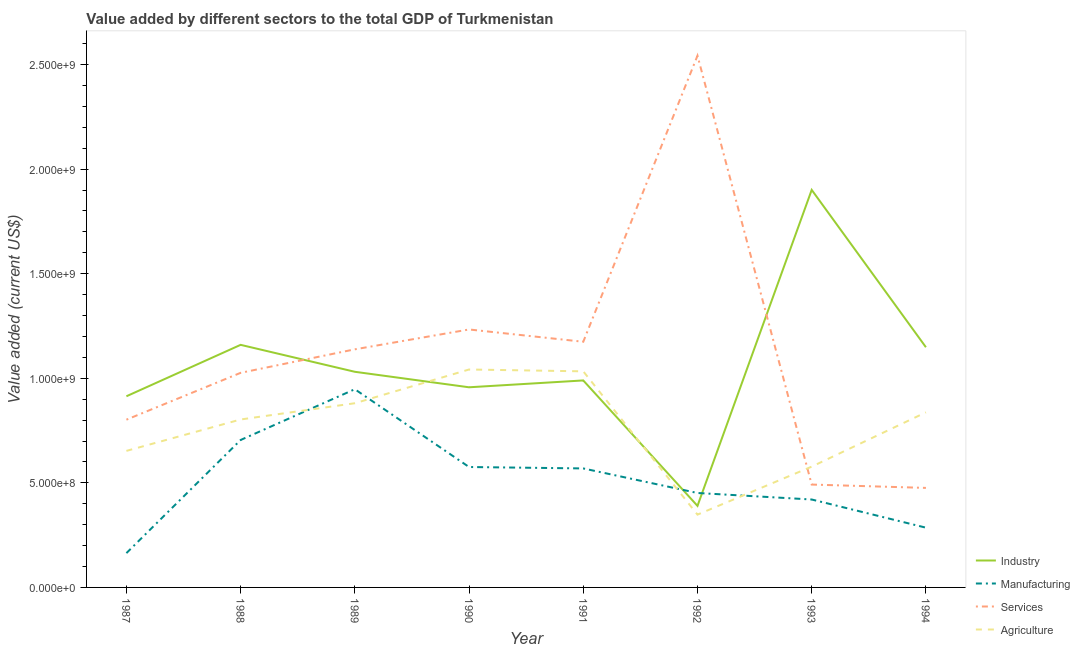Does the line corresponding to value added by manufacturing sector intersect with the line corresponding to value added by agricultural sector?
Provide a short and direct response. Yes. Is the number of lines equal to the number of legend labels?
Your answer should be compact. Yes. What is the value added by services sector in 1992?
Provide a succinct answer. 2.54e+09. Across all years, what is the maximum value added by agricultural sector?
Your answer should be compact. 1.04e+09. Across all years, what is the minimum value added by agricultural sector?
Offer a terse response. 3.48e+08. In which year was the value added by industrial sector maximum?
Ensure brevity in your answer.  1993. In which year was the value added by agricultural sector minimum?
Give a very brief answer. 1992. What is the total value added by agricultural sector in the graph?
Ensure brevity in your answer.  6.17e+09. What is the difference between the value added by industrial sector in 1990 and that in 1994?
Ensure brevity in your answer.  -1.92e+08. What is the difference between the value added by industrial sector in 1992 and the value added by manufacturing sector in 1988?
Your response must be concise. -3.15e+08. What is the average value added by services sector per year?
Provide a succinct answer. 1.11e+09. In the year 1990, what is the difference between the value added by industrial sector and value added by services sector?
Ensure brevity in your answer.  -2.76e+08. What is the ratio of the value added by industrial sector in 1989 to that in 1994?
Provide a succinct answer. 0.9. Is the value added by services sector in 1988 less than that in 1991?
Offer a terse response. Yes. Is the difference between the value added by manufacturing sector in 1988 and 1993 greater than the difference between the value added by industrial sector in 1988 and 1993?
Your answer should be very brief. Yes. What is the difference between the highest and the second highest value added by industrial sector?
Your answer should be compact. 7.41e+08. What is the difference between the highest and the lowest value added by agricultural sector?
Your answer should be very brief. 6.94e+08. Is it the case that in every year, the sum of the value added by services sector and value added by industrial sector is greater than the sum of value added by agricultural sector and value added by manufacturing sector?
Provide a short and direct response. No. Is it the case that in every year, the sum of the value added by industrial sector and value added by manufacturing sector is greater than the value added by services sector?
Provide a short and direct response. No. How many lines are there?
Offer a very short reply. 4. How many years are there in the graph?
Your answer should be compact. 8. What is the difference between two consecutive major ticks on the Y-axis?
Give a very brief answer. 5.00e+08. Does the graph contain any zero values?
Provide a succinct answer. No. Does the graph contain grids?
Keep it short and to the point. No. Where does the legend appear in the graph?
Give a very brief answer. Bottom right. How many legend labels are there?
Your response must be concise. 4. How are the legend labels stacked?
Your answer should be compact. Vertical. What is the title of the graph?
Offer a terse response. Value added by different sectors to the total GDP of Turkmenistan. What is the label or title of the Y-axis?
Offer a terse response. Value added (current US$). What is the Value added (current US$) in Industry in 1987?
Offer a terse response. 9.14e+08. What is the Value added (current US$) of Manufacturing in 1987?
Provide a succinct answer. 1.64e+08. What is the Value added (current US$) in Services in 1987?
Offer a terse response. 8.02e+08. What is the Value added (current US$) of Agriculture in 1987?
Keep it short and to the point. 6.53e+08. What is the Value added (current US$) in Industry in 1988?
Provide a succinct answer. 1.16e+09. What is the Value added (current US$) in Manufacturing in 1988?
Offer a very short reply. 7.05e+08. What is the Value added (current US$) of Services in 1988?
Provide a short and direct response. 1.03e+09. What is the Value added (current US$) of Agriculture in 1988?
Your answer should be compact. 8.03e+08. What is the Value added (current US$) in Industry in 1989?
Ensure brevity in your answer.  1.03e+09. What is the Value added (current US$) in Manufacturing in 1989?
Your answer should be compact. 9.48e+08. What is the Value added (current US$) in Services in 1989?
Offer a terse response. 1.14e+09. What is the Value added (current US$) in Agriculture in 1989?
Your answer should be very brief. 8.81e+08. What is the Value added (current US$) of Industry in 1990?
Give a very brief answer. 9.57e+08. What is the Value added (current US$) in Manufacturing in 1990?
Provide a short and direct response. 5.76e+08. What is the Value added (current US$) in Services in 1990?
Offer a terse response. 1.23e+09. What is the Value added (current US$) in Agriculture in 1990?
Your answer should be compact. 1.04e+09. What is the Value added (current US$) in Industry in 1991?
Give a very brief answer. 9.90e+08. What is the Value added (current US$) of Manufacturing in 1991?
Make the answer very short. 5.69e+08. What is the Value added (current US$) in Services in 1991?
Your answer should be very brief. 1.17e+09. What is the Value added (current US$) in Agriculture in 1991?
Keep it short and to the point. 1.03e+09. What is the Value added (current US$) in Industry in 1992?
Your response must be concise. 3.90e+08. What is the Value added (current US$) in Manufacturing in 1992?
Your answer should be compact. 4.52e+08. What is the Value added (current US$) of Services in 1992?
Provide a short and direct response. 2.54e+09. What is the Value added (current US$) in Agriculture in 1992?
Give a very brief answer. 3.48e+08. What is the Value added (current US$) in Industry in 1993?
Your answer should be very brief. 1.90e+09. What is the Value added (current US$) in Manufacturing in 1993?
Make the answer very short. 4.20e+08. What is the Value added (current US$) of Services in 1993?
Keep it short and to the point. 4.92e+08. What is the Value added (current US$) of Agriculture in 1993?
Provide a short and direct response. 5.77e+08. What is the Value added (current US$) of Industry in 1994?
Keep it short and to the point. 1.15e+09. What is the Value added (current US$) in Manufacturing in 1994?
Provide a short and direct response. 2.86e+08. What is the Value added (current US$) of Services in 1994?
Offer a terse response. 4.76e+08. What is the Value added (current US$) of Agriculture in 1994?
Your answer should be very brief. 8.37e+08. Across all years, what is the maximum Value added (current US$) of Industry?
Provide a short and direct response. 1.90e+09. Across all years, what is the maximum Value added (current US$) in Manufacturing?
Make the answer very short. 9.48e+08. Across all years, what is the maximum Value added (current US$) in Services?
Your answer should be very brief. 2.54e+09. Across all years, what is the maximum Value added (current US$) of Agriculture?
Offer a terse response. 1.04e+09. Across all years, what is the minimum Value added (current US$) in Industry?
Offer a terse response. 3.90e+08. Across all years, what is the minimum Value added (current US$) of Manufacturing?
Give a very brief answer. 1.64e+08. Across all years, what is the minimum Value added (current US$) of Services?
Your answer should be compact. 4.76e+08. Across all years, what is the minimum Value added (current US$) of Agriculture?
Your answer should be compact. 3.48e+08. What is the total Value added (current US$) in Industry in the graph?
Give a very brief answer. 8.49e+09. What is the total Value added (current US$) in Manufacturing in the graph?
Provide a succinct answer. 4.12e+09. What is the total Value added (current US$) in Services in the graph?
Your answer should be compact. 8.88e+09. What is the total Value added (current US$) in Agriculture in the graph?
Your answer should be compact. 6.17e+09. What is the difference between the Value added (current US$) of Industry in 1987 and that in 1988?
Offer a terse response. -2.46e+08. What is the difference between the Value added (current US$) in Manufacturing in 1987 and that in 1988?
Your answer should be very brief. -5.41e+08. What is the difference between the Value added (current US$) in Services in 1987 and that in 1988?
Your answer should be compact. -2.24e+08. What is the difference between the Value added (current US$) in Agriculture in 1987 and that in 1988?
Your answer should be very brief. -1.50e+08. What is the difference between the Value added (current US$) of Industry in 1987 and that in 1989?
Provide a succinct answer. -1.17e+08. What is the difference between the Value added (current US$) in Manufacturing in 1987 and that in 1989?
Offer a terse response. -7.84e+08. What is the difference between the Value added (current US$) in Services in 1987 and that in 1989?
Your answer should be very brief. -3.36e+08. What is the difference between the Value added (current US$) in Agriculture in 1987 and that in 1989?
Offer a very short reply. -2.28e+08. What is the difference between the Value added (current US$) of Industry in 1987 and that in 1990?
Give a very brief answer. -4.30e+07. What is the difference between the Value added (current US$) of Manufacturing in 1987 and that in 1990?
Make the answer very short. -4.12e+08. What is the difference between the Value added (current US$) in Services in 1987 and that in 1990?
Make the answer very short. -4.31e+08. What is the difference between the Value added (current US$) in Agriculture in 1987 and that in 1990?
Ensure brevity in your answer.  -3.89e+08. What is the difference between the Value added (current US$) in Industry in 1987 and that in 1991?
Your answer should be very brief. -7.57e+07. What is the difference between the Value added (current US$) of Manufacturing in 1987 and that in 1991?
Your answer should be compact. -4.05e+08. What is the difference between the Value added (current US$) of Services in 1987 and that in 1991?
Make the answer very short. -3.73e+08. What is the difference between the Value added (current US$) in Agriculture in 1987 and that in 1991?
Provide a succinct answer. -3.80e+08. What is the difference between the Value added (current US$) of Industry in 1987 and that in 1992?
Offer a very short reply. 5.24e+08. What is the difference between the Value added (current US$) in Manufacturing in 1987 and that in 1992?
Your answer should be compact. -2.87e+08. What is the difference between the Value added (current US$) in Services in 1987 and that in 1992?
Your answer should be compact. -1.74e+09. What is the difference between the Value added (current US$) in Agriculture in 1987 and that in 1992?
Your response must be concise. 3.05e+08. What is the difference between the Value added (current US$) of Industry in 1987 and that in 1993?
Provide a short and direct response. -9.87e+08. What is the difference between the Value added (current US$) in Manufacturing in 1987 and that in 1993?
Give a very brief answer. -2.56e+08. What is the difference between the Value added (current US$) in Services in 1987 and that in 1993?
Your answer should be compact. 3.10e+08. What is the difference between the Value added (current US$) in Agriculture in 1987 and that in 1993?
Your response must be concise. 7.53e+07. What is the difference between the Value added (current US$) in Industry in 1987 and that in 1994?
Ensure brevity in your answer.  -2.34e+08. What is the difference between the Value added (current US$) of Manufacturing in 1987 and that in 1994?
Make the answer very short. -1.22e+08. What is the difference between the Value added (current US$) of Services in 1987 and that in 1994?
Give a very brief answer. 3.26e+08. What is the difference between the Value added (current US$) of Agriculture in 1987 and that in 1994?
Offer a very short reply. -1.84e+08. What is the difference between the Value added (current US$) in Industry in 1988 and that in 1989?
Ensure brevity in your answer.  1.29e+08. What is the difference between the Value added (current US$) of Manufacturing in 1988 and that in 1989?
Your answer should be very brief. -2.43e+08. What is the difference between the Value added (current US$) in Services in 1988 and that in 1989?
Make the answer very short. -1.12e+08. What is the difference between the Value added (current US$) of Agriculture in 1988 and that in 1989?
Offer a terse response. -7.77e+07. What is the difference between the Value added (current US$) of Industry in 1988 and that in 1990?
Your answer should be very brief. 2.03e+08. What is the difference between the Value added (current US$) in Manufacturing in 1988 and that in 1990?
Offer a very short reply. 1.29e+08. What is the difference between the Value added (current US$) of Services in 1988 and that in 1990?
Your response must be concise. -2.07e+08. What is the difference between the Value added (current US$) of Agriculture in 1988 and that in 1990?
Your answer should be compact. -2.39e+08. What is the difference between the Value added (current US$) in Industry in 1988 and that in 1991?
Offer a terse response. 1.70e+08. What is the difference between the Value added (current US$) of Manufacturing in 1988 and that in 1991?
Your answer should be very brief. 1.36e+08. What is the difference between the Value added (current US$) in Services in 1988 and that in 1991?
Give a very brief answer. -1.49e+08. What is the difference between the Value added (current US$) in Agriculture in 1988 and that in 1991?
Give a very brief answer. -2.30e+08. What is the difference between the Value added (current US$) in Industry in 1988 and that in 1992?
Your answer should be very brief. 7.70e+08. What is the difference between the Value added (current US$) of Manufacturing in 1988 and that in 1992?
Offer a very short reply. 2.53e+08. What is the difference between the Value added (current US$) of Services in 1988 and that in 1992?
Keep it short and to the point. -1.52e+09. What is the difference between the Value added (current US$) of Agriculture in 1988 and that in 1992?
Keep it short and to the point. 4.55e+08. What is the difference between the Value added (current US$) in Industry in 1988 and that in 1993?
Your answer should be compact. -7.41e+08. What is the difference between the Value added (current US$) of Manufacturing in 1988 and that in 1993?
Make the answer very short. 2.85e+08. What is the difference between the Value added (current US$) in Services in 1988 and that in 1993?
Offer a terse response. 5.34e+08. What is the difference between the Value added (current US$) of Agriculture in 1988 and that in 1993?
Keep it short and to the point. 2.25e+08. What is the difference between the Value added (current US$) in Industry in 1988 and that in 1994?
Ensure brevity in your answer.  1.14e+07. What is the difference between the Value added (current US$) in Manufacturing in 1988 and that in 1994?
Your answer should be compact. 4.19e+08. What is the difference between the Value added (current US$) of Services in 1988 and that in 1994?
Provide a succinct answer. 5.50e+08. What is the difference between the Value added (current US$) in Agriculture in 1988 and that in 1994?
Your response must be concise. -3.41e+07. What is the difference between the Value added (current US$) of Industry in 1989 and that in 1990?
Your answer should be very brief. 7.41e+07. What is the difference between the Value added (current US$) of Manufacturing in 1989 and that in 1990?
Your answer should be compact. 3.72e+08. What is the difference between the Value added (current US$) in Services in 1989 and that in 1990?
Your answer should be compact. -9.49e+07. What is the difference between the Value added (current US$) in Agriculture in 1989 and that in 1990?
Your answer should be very brief. -1.61e+08. What is the difference between the Value added (current US$) in Industry in 1989 and that in 1991?
Your answer should be compact. 4.14e+07. What is the difference between the Value added (current US$) in Manufacturing in 1989 and that in 1991?
Offer a terse response. 3.79e+08. What is the difference between the Value added (current US$) of Services in 1989 and that in 1991?
Your answer should be compact. -3.61e+07. What is the difference between the Value added (current US$) of Agriculture in 1989 and that in 1991?
Your response must be concise. -1.52e+08. What is the difference between the Value added (current US$) in Industry in 1989 and that in 1992?
Your answer should be compact. 6.41e+08. What is the difference between the Value added (current US$) of Manufacturing in 1989 and that in 1992?
Keep it short and to the point. 4.96e+08. What is the difference between the Value added (current US$) in Services in 1989 and that in 1992?
Your response must be concise. -1.40e+09. What is the difference between the Value added (current US$) of Agriculture in 1989 and that in 1992?
Your answer should be compact. 5.33e+08. What is the difference between the Value added (current US$) of Industry in 1989 and that in 1993?
Provide a succinct answer. -8.70e+08. What is the difference between the Value added (current US$) in Manufacturing in 1989 and that in 1993?
Provide a short and direct response. 5.27e+08. What is the difference between the Value added (current US$) of Services in 1989 and that in 1993?
Give a very brief answer. 6.47e+08. What is the difference between the Value added (current US$) in Agriculture in 1989 and that in 1993?
Provide a short and direct response. 3.03e+08. What is the difference between the Value added (current US$) in Industry in 1989 and that in 1994?
Ensure brevity in your answer.  -1.17e+08. What is the difference between the Value added (current US$) in Manufacturing in 1989 and that in 1994?
Your answer should be very brief. 6.62e+08. What is the difference between the Value added (current US$) in Services in 1989 and that in 1994?
Your response must be concise. 6.63e+08. What is the difference between the Value added (current US$) of Agriculture in 1989 and that in 1994?
Make the answer very short. 4.36e+07. What is the difference between the Value added (current US$) in Industry in 1990 and that in 1991?
Keep it short and to the point. -3.28e+07. What is the difference between the Value added (current US$) in Manufacturing in 1990 and that in 1991?
Your answer should be compact. 6.83e+06. What is the difference between the Value added (current US$) in Services in 1990 and that in 1991?
Provide a short and direct response. 5.88e+07. What is the difference between the Value added (current US$) in Agriculture in 1990 and that in 1991?
Keep it short and to the point. 8.80e+06. What is the difference between the Value added (current US$) in Industry in 1990 and that in 1992?
Provide a short and direct response. 5.67e+08. What is the difference between the Value added (current US$) of Manufacturing in 1990 and that in 1992?
Offer a very short reply. 1.24e+08. What is the difference between the Value added (current US$) of Services in 1990 and that in 1992?
Your answer should be compact. -1.31e+09. What is the difference between the Value added (current US$) in Agriculture in 1990 and that in 1992?
Give a very brief answer. 6.94e+08. What is the difference between the Value added (current US$) of Industry in 1990 and that in 1993?
Make the answer very short. -9.44e+08. What is the difference between the Value added (current US$) in Manufacturing in 1990 and that in 1993?
Ensure brevity in your answer.  1.55e+08. What is the difference between the Value added (current US$) of Services in 1990 and that in 1993?
Offer a terse response. 7.41e+08. What is the difference between the Value added (current US$) in Agriculture in 1990 and that in 1993?
Offer a terse response. 4.64e+08. What is the difference between the Value added (current US$) in Industry in 1990 and that in 1994?
Give a very brief answer. -1.92e+08. What is the difference between the Value added (current US$) in Manufacturing in 1990 and that in 1994?
Offer a terse response. 2.90e+08. What is the difference between the Value added (current US$) of Services in 1990 and that in 1994?
Provide a succinct answer. 7.57e+08. What is the difference between the Value added (current US$) of Agriculture in 1990 and that in 1994?
Give a very brief answer. 2.05e+08. What is the difference between the Value added (current US$) of Industry in 1991 and that in 1992?
Make the answer very short. 6.00e+08. What is the difference between the Value added (current US$) of Manufacturing in 1991 and that in 1992?
Ensure brevity in your answer.  1.17e+08. What is the difference between the Value added (current US$) of Services in 1991 and that in 1992?
Your response must be concise. -1.37e+09. What is the difference between the Value added (current US$) in Agriculture in 1991 and that in 1992?
Give a very brief answer. 6.85e+08. What is the difference between the Value added (current US$) of Industry in 1991 and that in 1993?
Offer a terse response. -9.11e+08. What is the difference between the Value added (current US$) of Manufacturing in 1991 and that in 1993?
Your answer should be very brief. 1.49e+08. What is the difference between the Value added (current US$) in Services in 1991 and that in 1993?
Give a very brief answer. 6.83e+08. What is the difference between the Value added (current US$) in Agriculture in 1991 and that in 1993?
Your response must be concise. 4.56e+08. What is the difference between the Value added (current US$) of Industry in 1991 and that in 1994?
Keep it short and to the point. -1.59e+08. What is the difference between the Value added (current US$) in Manufacturing in 1991 and that in 1994?
Keep it short and to the point. 2.83e+08. What is the difference between the Value added (current US$) of Services in 1991 and that in 1994?
Your response must be concise. 6.99e+08. What is the difference between the Value added (current US$) in Agriculture in 1991 and that in 1994?
Your answer should be compact. 1.96e+08. What is the difference between the Value added (current US$) in Industry in 1992 and that in 1993?
Make the answer very short. -1.51e+09. What is the difference between the Value added (current US$) of Manufacturing in 1992 and that in 1993?
Offer a terse response. 3.12e+07. What is the difference between the Value added (current US$) of Services in 1992 and that in 1993?
Provide a succinct answer. 2.05e+09. What is the difference between the Value added (current US$) in Agriculture in 1992 and that in 1993?
Make the answer very short. -2.29e+08. What is the difference between the Value added (current US$) in Industry in 1992 and that in 1994?
Your response must be concise. -7.58e+08. What is the difference between the Value added (current US$) in Manufacturing in 1992 and that in 1994?
Your answer should be compact. 1.66e+08. What is the difference between the Value added (current US$) of Services in 1992 and that in 1994?
Offer a very short reply. 2.07e+09. What is the difference between the Value added (current US$) of Agriculture in 1992 and that in 1994?
Provide a short and direct response. -4.89e+08. What is the difference between the Value added (current US$) of Industry in 1993 and that in 1994?
Give a very brief answer. 7.52e+08. What is the difference between the Value added (current US$) of Manufacturing in 1993 and that in 1994?
Provide a succinct answer. 1.35e+08. What is the difference between the Value added (current US$) of Services in 1993 and that in 1994?
Your response must be concise. 1.60e+07. What is the difference between the Value added (current US$) of Agriculture in 1993 and that in 1994?
Provide a short and direct response. -2.60e+08. What is the difference between the Value added (current US$) of Industry in 1987 and the Value added (current US$) of Manufacturing in 1988?
Offer a very short reply. 2.09e+08. What is the difference between the Value added (current US$) in Industry in 1987 and the Value added (current US$) in Services in 1988?
Keep it short and to the point. -1.12e+08. What is the difference between the Value added (current US$) in Industry in 1987 and the Value added (current US$) in Agriculture in 1988?
Provide a short and direct response. 1.11e+08. What is the difference between the Value added (current US$) of Manufacturing in 1987 and the Value added (current US$) of Services in 1988?
Ensure brevity in your answer.  -8.62e+08. What is the difference between the Value added (current US$) in Manufacturing in 1987 and the Value added (current US$) in Agriculture in 1988?
Provide a succinct answer. -6.39e+08. What is the difference between the Value added (current US$) of Services in 1987 and the Value added (current US$) of Agriculture in 1988?
Your response must be concise. -9.41e+05. What is the difference between the Value added (current US$) in Industry in 1987 and the Value added (current US$) in Manufacturing in 1989?
Provide a succinct answer. -3.37e+07. What is the difference between the Value added (current US$) in Industry in 1987 and the Value added (current US$) in Services in 1989?
Provide a short and direct response. -2.24e+08. What is the difference between the Value added (current US$) in Industry in 1987 and the Value added (current US$) in Agriculture in 1989?
Your response must be concise. 3.33e+07. What is the difference between the Value added (current US$) in Manufacturing in 1987 and the Value added (current US$) in Services in 1989?
Keep it short and to the point. -9.74e+08. What is the difference between the Value added (current US$) of Manufacturing in 1987 and the Value added (current US$) of Agriculture in 1989?
Make the answer very short. -7.17e+08. What is the difference between the Value added (current US$) of Services in 1987 and the Value added (current US$) of Agriculture in 1989?
Provide a short and direct response. -7.86e+07. What is the difference between the Value added (current US$) in Industry in 1987 and the Value added (current US$) in Manufacturing in 1990?
Ensure brevity in your answer.  3.38e+08. What is the difference between the Value added (current US$) in Industry in 1987 and the Value added (current US$) in Services in 1990?
Give a very brief answer. -3.19e+08. What is the difference between the Value added (current US$) of Industry in 1987 and the Value added (current US$) of Agriculture in 1990?
Keep it short and to the point. -1.28e+08. What is the difference between the Value added (current US$) of Manufacturing in 1987 and the Value added (current US$) of Services in 1990?
Offer a terse response. -1.07e+09. What is the difference between the Value added (current US$) of Manufacturing in 1987 and the Value added (current US$) of Agriculture in 1990?
Your response must be concise. -8.78e+08. What is the difference between the Value added (current US$) in Services in 1987 and the Value added (current US$) in Agriculture in 1990?
Your response must be concise. -2.40e+08. What is the difference between the Value added (current US$) of Industry in 1987 and the Value added (current US$) of Manufacturing in 1991?
Your answer should be compact. 3.45e+08. What is the difference between the Value added (current US$) of Industry in 1987 and the Value added (current US$) of Services in 1991?
Give a very brief answer. -2.61e+08. What is the difference between the Value added (current US$) of Industry in 1987 and the Value added (current US$) of Agriculture in 1991?
Ensure brevity in your answer.  -1.19e+08. What is the difference between the Value added (current US$) in Manufacturing in 1987 and the Value added (current US$) in Services in 1991?
Ensure brevity in your answer.  -1.01e+09. What is the difference between the Value added (current US$) in Manufacturing in 1987 and the Value added (current US$) in Agriculture in 1991?
Offer a very short reply. -8.69e+08. What is the difference between the Value added (current US$) of Services in 1987 and the Value added (current US$) of Agriculture in 1991?
Your answer should be compact. -2.31e+08. What is the difference between the Value added (current US$) in Industry in 1987 and the Value added (current US$) in Manufacturing in 1992?
Your answer should be compact. 4.62e+08. What is the difference between the Value added (current US$) of Industry in 1987 and the Value added (current US$) of Services in 1992?
Your answer should be compact. -1.63e+09. What is the difference between the Value added (current US$) of Industry in 1987 and the Value added (current US$) of Agriculture in 1992?
Your answer should be very brief. 5.66e+08. What is the difference between the Value added (current US$) of Manufacturing in 1987 and the Value added (current US$) of Services in 1992?
Your answer should be very brief. -2.38e+09. What is the difference between the Value added (current US$) of Manufacturing in 1987 and the Value added (current US$) of Agriculture in 1992?
Your answer should be very brief. -1.84e+08. What is the difference between the Value added (current US$) of Services in 1987 and the Value added (current US$) of Agriculture in 1992?
Offer a very short reply. 4.54e+08. What is the difference between the Value added (current US$) of Industry in 1987 and the Value added (current US$) of Manufacturing in 1993?
Ensure brevity in your answer.  4.94e+08. What is the difference between the Value added (current US$) of Industry in 1987 and the Value added (current US$) of Services in 1993?
Your answer should be very brief. 4.22e+08. What is the difference between the Value added (current US$) of Industry in 1987 and the Value added (current US$) of Agriculture in 1993?
Offer a very short reply. 3.36e+08. What is the difference between the Value added (current US$) in Manufacturing in 1987 and the Value added (current US$) in Services in 1993?
Make the answer very short. -3.28e+08. What is the difference between the Value added (current US$) in Manufacturing in 1987 and the Value added (current US$) in Agriculture in 1993?
Give a very brief answer. -4.13e+08. What is the difference between the Value added (current US$) of Services in 1987 and the Value added (current US$) of Agriculture in 1993?
Ensure brevity in your answer.  2.25e+08. What is the difference between the Value added (current US$) in Industry in 1987 and the Value added (current US$) in Manufacturing in 1994?
Give a very brief answer. 6.28e+08. What is the difference between the Value added (current US$) of Industry in 1987 and the Value added (current US$) of Services in 1994?
Your answer should be very brief. 4.38e+08. What is the difference between the Value added (current US$) in Industry in 1987 and the Value added (current US$) in Agriculture in 1994?
Ensure brevity in your answer.  7.68e+07. What is the difference between the Value added (current US$) of Manufacturing in 1987 and the Value added (current US$) of Services in 1994?
Ensure brevity in your answer.  -3.12e+08. What is the difference between the Value added (current US$) of Manufacturing in 1987 and the Value added (current US$) of Agriculture in 1994?
Make the answer very short. -6.73e+08. What is the difference between the Value added (current US$) in Services in 1987 and the Value added (current US$) in Agriculture in 1994?
Make the answer very short. -3.51e+07. What is the difference between the Value added (current US$) in Industry in 1988 and the Value added (current US$) in Manufacturing in 1989?
Your response must be concise. 2.12e+08. What is the difference between the Value added (current US$) in Industry in 1988 and the Value added (current US$) in Services in 1989?
Your answer should be very brief. 2.14e+07. What is the difference between the Value added (current US$) in Industry in 1988 and the Value added (current US$) in Agriculture in 1989?
Offer a terse response. 2.79e+08. What is the difference between the Value added (current US$) of Manufacturing in 1988 and the Value added (current US$) of Services in 1989?
Your answer should be compact. -4.33e+08. What is the difference between the Value added (current US$) in Manufacturing in 1988 and the Value added (current US$) in Agriculture in 1989?
Offer a very short reply. -1.76e+08. What is the difference between the Value added (current US$) of Services in 1988 and the Value added (current US$) of Agriculture in 1989?
Give a very brief answer. 1.45e+08. What is the difference between the Value added (current US$) of Industry in 1988 and the Value added (current US$) of Manufacturing in 1990?
Provide a short and direct response. 5.84e+08. What is the difference between the Value added (current US$) of Industry in 1988 and the Value added (current US$) of Services in 1990?
Make the answer very short. -7.35e+07. What is the difference between the Value added (current US$) of Industry in 1988 and the Value added (current US$) of Agriculture in 1990?
Provide a short and direct response. 1.18e+08. What is the difference between the Value added (current US$) in Manufacturing in 1988 and the Value added (current US$) in Services in 1990?
Provide a short and direct response. -5.28e+08. What is the difference between the Value added (current US$) in Manufacturing in 1988 and the Value added (current US$) in Agriculture in 1990?
Offer a very short reply. -3.37e+08. What is the difference between the Value added (current US$) in Services in 1988 and the Value added (current US$) in Agriculture in 1990?
Your answer should be very brief. -1.60e+07. What is the difference between the Value added (current US$) of Industry in 1988 and the Value added (current US$) of Manufacturing in 1991?
Offer a very short reply. 5.91e+08. What is the difference between the Value added (current US$) of Industry in 1988 and the Value added (current US$) of Services in 1991?
Offer a very short reply. -1.47e+07. What is the difference between the Value added (current US$) in Industry in 1988 and the Value added (current US$) in Agriculture in 1991?
Your answer should be compact. 1.27e+08. What is the difference between the Value added (current US$) in Manufacturing in 1988 and the Value added (current US$) in Services in 1991?
Give a very brief answer. -4.70e+08. What is the difference between the Value added (current US$) in Manufacturing in 1988 and the Value added (current US$) in Agriculture in 1991?
Provide a short and direct response. -3.28e+08. What is the difference between the Value added (current US$) of Services in 1988 and the Value added (current US$) of Agriculture in 1991?
Keep it short and to the point. -7.15e+06. What is the difference between the Value added (current US$) in Industry in 1988 and the Value added (current US$) in Manufacturing in 1992?
Provide a succinct answer. 7.08e+08. What is the difference between the Value added (current US$) in Industry in 1988 and the Value added (current US$) in Services in 1992?
Provide a short and direct response. -1.38e+09. What is the difference between the Value added (current US$) of Industry in 1988 and the Value added (current US$) of Agriculture in 1992?
Offer a terse response. 8.12e+08. What is the difference between the Value added (current US$) in Manufacturing in 1988 and the Value added (current US$) in Services in 1992?
Make the answer very short. -1.84e+09. What is the difference between the Value added (current US$) in Manufacturing in 1988 and the Value added (current US$) in Agriculture in 1992?
Provide a succinct answer. 3.57e+08. What is the difference between the Value added (current US$) in Services in 1988 and the Value added (current US$) in Agriculture in 1992?
Ensure brevity in your answer.  6.78e+08. What is the difference between the Value added (current US$) in Industry in 1988 and the Value added (current US$) in Manufacturing in 1993?
Your response must be concise. 7.39e+08. What is the difference between the Value added (current US$) in Industry in 1988 and the Value added (current US$) in Services in 1993?
Ensure brevity in your answer.  6.68e+08. What is the difference between the Value added (current US$) of Industry in 1988 and the Value added (current US$) of Agriculture in 1993?
Provide a succinct answer. 5.82e+08. What is the difference between the Value added (current US$) in Manufacturing in 1988 and the Value added (current US$) in Services in 1993?
Offer a terse response. 2.13e+08. What is the difference between the Value added (current US$) of Manufacturing in 1988 and the Value added (current US$) of Agriculture in 1993?
Your answer should be compact. 1.27e+08. What is the difference between the Value added (current US$) of Services in 1988 and the Value added (current US$) of Agriculture in 1993?
Make the answer very short. 4.49e+08. What is the difference between the Value added (current US$) of Industry in 1988 and the Value added (current US$) of Manufacturing in 1994?
Offer a terse response. 8.74e+08. What is the difference between the Value added (current US$) of Industry in 1988 and the Value added (current US$) of Services in 1994?
Provide a succinct answer. 6.84e+08. What is the difference between the Value added (current US$) of Industry in 1988 and the Value added (current US$) of Agriculture in 1994?
Provide a short and direct response. 3.23e+08. What is the difference between the Value added (current US$) of Manufacturing in 1988 and the Value added (current US$) of Services in 1994?
Provide a succinct answer. 2.29e+08. What is the difference between the Value added (current US$) in Manufacturing in 1988 and the Value added (current US$) in Agriculture in 1994?
Your response must be concise. -1.32e+08. What is the difference between the Value added (current US$) in Services in 1988 and the Value added (current US$) in Agriculture in 1994?
Ensure brevity in your answer.  1.89e+08. What is the difference between the Value added (current US$) in Industry in 1989 and the Value added (current US$) in Manufacturing in 1990?
Keep it short and to the point. 4.55e+08. What is the difference between the Value added (current US$) in Industry in 1989 and the Value added (current US$) in Services in 1990?
Give a very brief answer. -2.02e+08. What is the difference between the Value added (current US$) in Industry in 1989 and the Value added (current US$) in Agriculture in 1990?
Keep it short and to the point. -1.09e+07. What is the difference between the Value added (current US$) of Manufacturing in 1989 and the Value added (current US$) of Services in 1990?
Provide a succinct answer. -2.86e+08. What is the difference between the Value added (current US$) in Manufacturing in 1989 and the Value added (current US$) in Agriculture in 1990?
Offer a terse response. -9.43e+07. What is the difference between the Value added (current US$) in Services in 1989 and the Value added (current US$) in Agriculture in 1990?
Make the answer very short. 9.64e+07. What is the difference between the Value added (current US$) in Industry in 1989 and the Value added (current US$) in Manufacturing in 1991?
Ensure brevity in your answer.  4.62e+08. What is the difference between the Value added (current US$) in Industry in 1989 and the Value added (current US$) in Services in 1991?
Keep it short and to the point. -1.44e+08. What is the difference between the Value added (current US$) of Industry in 1989 and the Value added (current US$) of Agriculture in 1991?
Provide a succinct answer. -2.15e+06. What is the difference between the Value added (current US$) of Manufacturing in 1989 and the Value added (current US$) of Services in 1991?
Give a very brief answer. -2.27e+08. What is the difference between the Value added (current US$) of Manufacturing in 1989 and the Value added (current US$) of Agriculture in 1991?
Provide a succinct answer. -8.55e+07. What is the difference between the Value added (current US$) of Services in 1989 and the Value added (current US$) of Agriculture in 1991?
Provide a short and direct response. 1.05e+08. What is the difference between the Value added (current US$) of Industry in 1989 and the Value added (current US$) of Manufacturing in 1992?
Provide a short and direct response. 5.79e+08. What is the difference between the Value added (current US$) of Industry in 1989 and the Value added (current US$) of Services in 1992?
Offer a terse response. -1.51e+09. What is the difference between the Value added (current US$) in Industry in 1989 and the Value added (current US$) in Agriculture in 1992?
Provide a succinct answer. 6.83e+08. What is the difference between the Value added (current US$) of Manufacturing in 1989 and the Value added (current US$) of Services in 1992?
Keep it short and to the point. -1.59e+09. What is the difference between the Value added (current US$) in Manufacturing in 1989 and the Value added (current US$) in Agriculture in 1992?
Provide a succinct answer. 6.00e+08. What is the difference between the Value added (current US$) in Services in 1989 and the Value added (current US$) in Agriculture in 1992?
Your response must be concise. 7.90e+08. What is the difference between the Value added (current US$) in Industry in 1989 and the Value added (current US$) in Manufacturing in 1993?
Provide a succinct answer. 6.11e+08. What is the difference between the Value added (current US$) in Industry in 1989 and the Value added (current US$) in Services in 1993?
Provide a succinct answer. 5.39e+08. What is the difference between the Value added (current US$) in Industry in 1989 and the Value added (current US$) in Agriculture in 1993?
Your answer should be compact. 4.54e+08. What is the difference between the Value added (current US$) in Manufacturing in 1989 and the Value added (current US$) in Services in 1993?
Your response must be concise. 4.56e+08. What is the difference between the Value added (current US$) of Manufacturing in 1989 and the Value added (current US$) of Agriculture in 1993?
Your answer should be very brief. 3.70e+08. What is the difference between the Value added (current US$) in Services in 1989 and the Value added (current US$) in Agriculture in 1993?
Keep it short and to the point. 5.61e+08. What is the difference between the Value added (current US$) of Industry in 1989 and the Value added (current US$) of Manufacturing in 1994?
Give a very brief answer. 7.45e+08. What is the difference between the Value added (current US$) in Industry in 1989 and the Value added (current US$) in Services in 1994?
Provide a short and direct response. 5.55e+08. What is the difference between the Value added (current US$) of Industry in 1989 and the Value added (current US$) of Agriculture in 1994?
Provide a short and direct response. 1.94e+08. What is the difference between the Value added (current US$) of Manufacturing in 1989 and the Value added (current US$) of Services in 1994?
Make the answer very short. 4.72e+08. What is the difference between the Value added (current US$) of Manufacturing in 1989 and the Value added (current US$) of Agriculture in 1994?
Ensure brevity in your answer.  1.11e+08. What is the difference between the Value added (current US$) of Services in 1989 and the Value added (current US$) of Agriculture in 1994?
Keep it short and to the point. 3.01e+08. What is the difference between the Value added (current US$) in Industry in 1990 and the Value added (current US$) in Manufacturing in 1991?
Ensure brevity in your answer.  3.88e+08. What is the difference between the Value added (current US$) in Industry in 1990 and the Value added (current US$) in Services in 1991?
Your response must be concise. -2.18e+08. What is the difference between the Value added (current US$) in Industry in 1990 and the Value added (current US$) in Agriculture in 1991?
Ensure brevity in your answer.  -7.63e+07. What is the difference between the Value added (current US$) of Manufacturing in 1990 and the Value added (current US$) of Services in 1991?
Your answer should be compact. -5.99e+08. What is the difference between the Value added (current US$) of Manufacturing in 1990 and the Value added (current US$) of Agriculture in 1991?
Your response must be concise. -4.57e+08. What is the difference between the Value added (current US$) in Services in 1990 and the Value added (current US$) in Agriculture in 1991?
Ensure brevity in your answer.  2.00e+08. What is the difference between the Value added (current US$) in Industry in 1990 and the Value added (current US$) in Manufacturing in 1992?
Provide a short and direct response. 5.05e+08. What is the difference between the Value added (current US$) of Industry in 1990 and the Value added (current US$) of Services in 1992?
Give a very brief answer. -1.59e+09. What is the difference between the Value added (current US$) of Industry in 1990 and the Value added (current US$) of Agriculture in 1992?
Keep it short and to the point. 6.09e+08. What is the difference between the Value added (current US$) in Manufacturing in 1990 and the Value added (current US$) in Services in 1992?
Ensure brevity in your answer.  -1.97e+09. What is the difference between the Value added (current US$) of Manufacturing in 1990 and the Value added (current US$) of Agriculture in 1992?
Give a very brief answer. 2.28e+08. What is the difference between the Value added (current US$) in Services in 1990 and the Value added (current US$) in Agriculture in 1992?
Ensure brevity in your answer.  8.85e+08. What is the difference between the Value added (current US$) of Industry in 1990 and the Value added (current US$) of Manufacturing in 1993?
Make the answer very short. 5.37e+08. What is the difference between the Value added (current US$) of Industry in 1990 and the Value added (current US$) of Services in 1993?
Provide a succinct answer. 4.65e+08. What is the difference between the Value added (current US$) of Industry in 1990 and the Value added (current US$) of Agriculture in 1993?
Offer a terse response. 3.79e+08. What is the difference between the Value added (current US$) in Manufacturing in 1990 and the Value added (current US$) in Services in 1993?
Ensure brevity in your answer.  8.39e+07. What is the difference between the Value added (current US$) of Manufacturing in 1990 and the Value added (current US$) of Agriculture in 1993?
Offer a terse response. -1.74e+06. What is the difference between the Value added (current US$) in Services in 1990 and the Value added (current US$) in Agriculture in 1993?
Your response must be concise. 6.56e+08. What is the difference between the Value added (current US$) in Industry in 1990 and the Value added (current US$) in Manufacturing in 1994?
Make the answer very short. 6.71e+08. What is the difference between the Value added (current US$) of Industry in 1990 and the Value added (current US$) of Services in 1994?
Offer a very short reply. 4.81e+08. What is the difference between the Value added (current US$) of Industry in 1990 and the Value added (current US$) of Agriculture in 1994?
Provide a succinct answer. 1.20e+08. What is the difference between the Value added (current US$) of Manufacturing in 1990 and the Value added (current US$) of Services in 1994?
Give a very brief answer. 9.99e+07. What is the difference between the Value added (current US$) of Manufacturing in 1990 and the Value added (current US$) of Agriculture in 1994?
Ensure brevity in your answer.  -2.61e+08. What is the difference between the Value added (current US$) in Services in 1990 and the Value added (current US$) in Agriculture in 1994?
Provide a succinct answer. 3.96e+08. What is the difference between the Value added (current US$) of Industry in 1991 and the Value added (current US$) of Manufacturing in 1992?
Keep it short and to the point. 5.38e+08. What is the difference between the Value added (current US$) in Industry in 1991 and the Value added (current US$) in Services in 1992?
Provide a short and direct response. -1.55e+09. What is the difference between the Value added (current US$) in Industry in 1991 and the Value added (current US$) in Agriculture in 1992?
Provide a succinct answer. 6.42e+08. What is the difference between the Value added (current US$) in Manufacturing in 1991 and the Value added (current US$) in Services in 1992?
Your answer should be very brief. -1.97e+09. What is the difference between the Value added (current US$) of Manufacturing in 1991 and the Value added (current US$) of Agriculture in 1992?
Offer a terse response. 2.21e+08. What is the difference between the Value added (current US$) of Services in 1991 and the Value added (current US$) of Agriculture in 1992?
Offer a very short reply. 8.26e+08. What is the difference between the Value added (current US$) of Industry in 1991 and the Value added (current US$) of Manufacturing in 1993?
Keep it short and to the point. 5.69e+08. What is the difference between the Value added (current US$) in Industry in 1991 and the Value added (current US$) in Services in 1993?
Offer a terse response. 4.98e+08. What is the difference between the Value added (current US$) of Industry in 1991 and the Value added (current US$) of Agriculture in 1993?
Make the answer very short. 4.12e+08. What is the difference between the Value added (current US$) in Manufacturing in 1991 and the Value added (current US$) in Services in 1993?
Keep it short and to the point. 7.71e+07. What is the difference between the Value added (current US$) in Manufacturing in 1991 and the Value added (current US$) in Agriculture in 1993?
Give a very brief answer. -8.57e+06. What is the difference between the Value added (current US$) of Services in 1991 and the Value added (current US$) of Agriculture in 1993?
Your response must be concise. 5.97e+08. What is the difference between the Value added (current US$) in Industry in 1991 and the Value added (current US$) in Manufacturing in 1994?
Your answer should be compact. 7.04e+08. What is the difference between the Value added (current US$) in Industry in 1991 and the Value added (current US$) in Services in 1994?
Your answer should be compact. 5.14e+08. What is the difference between the Value added (current US$) in Industry in 1991 and the Value added (current US$) in Agriculture in 1994?
Keep it short and to the point. 1.53e+08. What is the difference between the Value added (current US$) in Manufacturing in 1991 and the Value added (current US$) in Services in 1994?
Provide a short and direct response. 9.31e+07. What is the difference between the Value added (current US$) of Manufacturing in 1991 and the Value added (current US$) of Agriculture in 1994?
Keep it short and to the point. -2.68e+08. What is the difference between the Value added (current US$) of Services in 1991 and the Value added (current US$) of Agriculture in 1994?
Ensure brevity in your answer.  3.37e+08. What is the difference between the Value added (current US$) in Industry in 1992 and the Value added (current US$) in Manufacturing in 1993?
Provide a succinct answer. -3.04e+07. What is the difference between the Value added (current US$) of Industry in 1992 and the Value added (current US$) of Services in 1993?
Your response must be concise. -1.02e+08. What is the difference between the Value added (current US$) in Industry in 1992 and the Value added (current US$) in Agriculture in 1993?
Make the answer very short. -1.88e+08. What is the difference between the Value added (current US$) in Manufacturing in 1992 and the Value added (current US$) in Services in 1993?
Ensure brevity in your answer.  -4.03e+07. What is the difference between the Value added (current US$) in Manufacturing in 1992 and the Value added (current US$) in Agriculture in 1993?
Provide a short and direct response. -1.26e+08. What is the difference between the Value added (current US$) of Services in 1992 and the Value added (current US$) of Agriculture in 1993?
Your response must be concise. 1.96e+09. What is the difference between the Value added (current US$) in Industry in 1992 and the Value added (current US$) in Manufacturing in 1994?
Offer a very short reply. 1.04e+08. What is the difference between the Value added (current US$) of Industry in 1992 and the Value added (current US$) of Services in 1994?
Offer a terse response. -8.59e+07. What is the difference between the Value added (current US$) in Industry in 1992 and the Value added (current US$) in Agriculture in 1994?
Ensure brevity in your answer.  -4.47e+08. What is the difference between the Value added (current US$) of Manufacturing in 1992 and the Value added (current US$) of Services in 1994?
Your answer should be compact. -2.43e+07. What is the difference between the Value added (current US$) in Manufacturing in 1992 and the Value added (current US$) in Agriculture in 1994?
Offer a very short reply. -3.86e+08. What is the difference between the Value added (current US$) in Services in 1992 and the Value added (current US$) in Agriculture in 1994?
Provide a short and direct response. 1.71e+09. What is the difference between the Value added (current US$) of Industry in 1993 and the Value added (current US$) of Manufacturing in 1994?
Provide a short and direct response. 1.61e+09. What is the difference between the Value added (current US$) in Industry in 1993 and the Value added (current US$) in Services in 1994?
Make the answer very short. 1.42e+09. What is the difference between the Value added (current US$) in Industry in 1993 and the Value added (current US$) in Agriculture in 1994?
Offer a very short reply. 1.06e+09. What is the difference between the Value added (current US$) in Manufacturing in 1993 and the Value added (current US$) in Services in 1994?
Your answer should be compact. -5.55e+07. What is the difference between the Value added (current US$) in Manufacturing in 1993 and the Value added (current US$) in Agriculture in 1994?
Provide a succinct answer. -4.17e+08. What is the difference between the Value added (current US$) in Services in 1993 and the Value added (current US$) in Agriculture in 1994?
Provide a short and direct response. -3.45e+08. What is the average Value added (current US$) in Industry per year?
Ensure brevity in your answer.  1.06e+09. What is the average Value added (current US$) of Manufacturing per year?
Offer a terse response. 5.15e+08. What is the average Value added (current US$) of Services per year?
Provide a short and direct response. 1.11e+09. What is the average Value added (current US$) of Agriculture per year?
Keep it short and to the point. 7.72e+08. In the year 1987, what is the difference between the Value added (current US$) in Industry and Value added (current US$) in Manufacturing?
Provide a succinct answer. 7.50e+08. In the year 1987, what is the difference between the Value added (current US$) in Industry and Value added (current US$) in Services?
Your answer should be very brief. 1.12e+08. In the year 1987, what is the difference between the Value added (current US$) in Industry and Value added (current US$) in Agriculture?
Make the answer very short. 2.61e+08. In the year 1987, what is the difference between the Value added (current US$) of Manufacturing and Value added (current US$) of Services?
Offer a terse response. -6.38e+08. In the year 1987, what is the difference between the Value added (current US$) in Manufacturing and Value added (current US$) in Agriculture?
Ensure brevity in your answer.  -4.89e+08. In the year 1987, what is the difference between the Value added (current US$) of Services and Value added (current US$) of Agriculture?
Give a very brief answer. 1.49e+08. In the year 1988, what is the difference between the Value added (current US$) of Industry and Value added (current US$) of Manufacturing?
Ensure brevity in your answer.  4.55e+08. In the year 1988, what is the difference between the Value added (current US$) in Industry and Value added (current US$) in Services?
Offer a very short reply. 1.34e+08. In the year 1988, what is the difference between the Value added (current US$) of Industry and Value added (current US$) of Agriculture?
Provide a succinct answer. 3.57e+08. In the year 1988, what is the difference between the Value added (current US$) of Manufacturing and Value added (current US$) of Services?
Your answer should be very brief. -3.21e+08. In the year 1988, what is the difference between the Value added (current US$) in Manufacturing and Value added (current US$) in Agriculture?
Give a very brief answer. -9.80e+07. In the year 1988, what is the difference between the Value added (current US$) in Services and Value added (current US$) in Agriculture?
Keep it short and to the point. 2.23e+08. In the year 1989, what is the difference between the Value added (current US$) in Industry and Value added (current US$) in Manufacturing?
Provide a short and direct response. 8.34e+07. In the year 1989, what is the difference between the Value added (current US$) in Industry and Value added (current US$) in Services?
Your answer should be compact. -1.07e+08. In the year 1989, what is the difference between the Value added (current US$) in Industry and Value added (current US$) in Agriculture?
Keep it short and to the point. 1.50e+08. In the year 1989, what is the difference between the Value added (current US$) of Manufacturing and Value added (current US$) of Services?
Give a very brief answer. -1.91e+08. In the year 1989, what is the difference between the Value added (current US$) in Manufacturing and Value added (current US$) in Agriculture?
Provide a short and direct response. 6.70e+07. In the year 1989, what is the difference between the Value added (current US$) of Services and Value added (current US$) of Agriculture?
Give a very brief answer. 2.58e+08. In the year 1990, what is the difference between the Value added (current US$) of Industry and Value added (current US$) of Manufacturing?
Keep it short and to the point. 3.81e+08. In the year 1990, what is the difference between the Value added (current US$) of Industry and Value added (current US$) of Services?
Make the answer very short. -2.76e+08. In the year 1990, what is the difference between the Value added (current US$) in Industry and Value added (current US$) in Agriculture?
Your answer should be compact. -8.51e+07. In the year 1990, what is the difference between the Value added (current US$) of Manufacturing and Value added (current US$) of Services?
Offer a very short reply. -6.58e+08. In the year 1990, what is the difference between the Value added (current US$) in Manufacturing and Value added (current US$) in Agriculture?
Your answer should be compact. -4.66e+08. In the year 1990, what is the difference between the Value added (current US$) in Services and Value added (current US$) in Agriculture?
Offer a terse response. 1.91e+08. In the year 1991, what is the difference between the Value added (current US$) of Industry and Value added (current US$) of Manufacturing?
Provide a short and direct response. 4.21e+08. In the year 1991, what is the difference between the Value added (current US$) of Industry and Value added (current US$) of Services?
Provide a short and direct response. -1.85e+08. In the year 1991, what is the difference between the Value added (current US$) of Industry and Value added (current US$) of Agriculture?
Make the answer very short. -4.35e+07. In the year 1991, what is the difference between the Value added (current US$) of Manufacturing and Value added (current US$) of Services?
Keep it short and to the point. -6.06e+08. In the year 1991, what is the difference between the Value added (current US$) in Manufacturing and Value added (current US$) in Agriculture?
Give a very brief answer. -4.64e+08. In the year 1991, what is the difference between the Value added (current US$) in Services and Value added (current US$) in Agriculture?
Your answer should be compact. 1.41e+08. In the year 1992, what is the difference between the Value added (current US$) in Industry and Value added (current US$) in Manufacturing?
Your answer should be very brief. -6.16e+07. In the year 1992, what is the difference between the Value added (current US$) in Industry and Value added (current US$) in Services?
Provide a succinct answer. -2.15e+09. In the year 1992, what is the difference between the Value added (current US$) of Industry and Value added (current US$) of Agriculture?
Offer a very short reply. 4.18e+07. In the year 1992, what is the difference between the Value added (current US$) of Manufacturing and Value added (current US$) of Services?
Ensure brevity in your answer.  -2.09e+09. In the year 1992, what is the difference between the Value added (current US$) in Manufacturing and Value added (current US$) in Agriculture?
Offer a terse response. 1.03e+08. In the year 1992, what is the difference between the Value added (current US$) of Services and Value added (current US$) of Agriculture?
Provide a short and direct response. 2.19e+09. In the year 1993, what is the difference between the Value added (current US$) of Industry and Value added (current US$) of Manufacturing?
Provide a short and direct response. 1.48e+09. In the year 1993, what is the difference between the Value added (current US$) of Industry and Value added (current US$) of Services?
Your answer should be compact. 1.41e+09. In the year 1993, what is the difference between the Value added (current US$) of Industry and Value added (current US$) of Agriculture?
Ensure brevity in your answer.  1.32e+09. In the year 1993, what is the difference between the Value added (current US$) of Manufacturing and Value added (current US$) of Services?
Give a very brief answer. -7.15e+07. In the year 1993, what is the difference between the Value added (current US$) in Manufacturing and Value added (current US$) in Agriculture?
Provide a short and direct response. -1.57e+08. In the year 1993, what is the difference between the Value added (current US$) of Services and Value added (current US$) of Agriculture?
Provide a short and direct response. -8.57e+07. In the year 1994, what is the difference between the Value added (current US$) of Industry and Value added (current US$) of Manufacturing?
Provide a succinct answer. 8.63e+08. In the year 1994, what is the difference between the Value added (current US$) of Industry and Value added (current US$) of Services?
Offer a very short reply. 6.73e+08. In the year 1994, what is the difference between the Value added (current US$) in Industry and Value added (current US$) in Agriculture?
Your answer should be very brief. 3.11e+08. In the year 1994, what is the difference between the Value added (current US$) of Manufacturing and Value added (current US$) of Services?
Offer a very short reply. -1.90e+08. In the year 1994, what is the difference between the Value added (current US$) of Manufacturing and Value added (current US$) of Agriculture?
Keep it short and to the point. -5.51e+08. In the year 1994, what is the difference between the Value added (current US$) in Services and Value added (current US$) in Agriculture?
Offer a terse response. -3.61e+08. What is the ratio of the Value added (current US$) of Industry in 1987 to that in 1988?
Your answer should be compact. 0.79. What is the ratio of the Value added (current US$) of Manufacturing in 1987 to that in 1988?
Offer a terse response. 0.23. What is the ratio of the Value added (current US$) of Services in 1987 to that in 1988?
Give a very brief answer. 0.78. What is the ratio of the Value added (current US$) in Agriculture in 1987 to that in 1988?
Your answer should be very brief. 0.81. What is the ratio of the Value added (current US$) in Industry in 1987 to that in 1989?
Your answer should be very brief. 0.89. What is the ratio of the Value added (current US$) in Manufacturing in 1987 to that in 1989?
Offer a terse response. 0.17. What is the ratio of the Value added (current US$) in Services in 1987 to that in 1989?
Keep it short and to the point. 0.7. What is the ratio of the Value added (current US$) of Agriculture in 1987 to that in 1989?
Your answer should be very brief. 0.74. What is the ratio of the Value added (current US$) in Industry in 1987 to that in 1990?
Ensure brevity in your answer.  0.96. What is the ratio of the Value added (current US$) of Manufacturing in 1987 to that in 1990?
Make the answer very short. 0.28. What is the ratio of the Value added (current US$) of Services in 1987 to that in 1990?
Your response must be concise. 0.65. What is the ratio of the Value added (current US$) of Agriculture in 1987 to that in 1990?
Make the answer very short. 0.63. What is the ratio of the Value added (current US$) in Industry in 1987 to that in 1991?
Give a very brief answer. 0.92. What is the ratio of the Value added (current US$) in Manufacturing in 1987 to that in 1991?
Offer a terse response. 0.29. What is the ratio of the Value added (current US$) in Services in 1987 to that in 1991?
Provide a succinct answer. 0.68. What is the ratio of the Value added (current US$) of Agriculture in 1987 to that in 1991?
Your response must be concise. 0.63. What is the ratio of the Value added (current US$) of Industry in 1987 to that in 1992?
Your answer should be compact. 2.34. What is the ratio of the Value added (current US$) of Manufacturing in 1987 to that in 1992?
Your answer should be very brief. 0.36. What is the ratio of the Value added (current US$) in Services in 1987 to that in 1992?
Offer a terse response. 0.32. What is the ratio of the Value added (current US$) in Agriculture in 1987 to that in 1992?
Ensure brevity in your answer.  1.88. What is the ratio of the Value added (current US$) of Industry in 1987 to that in 1993?
Offer a terse response. 0.48. What is the ratio of the Value added (current US$) in Manufacturing in 1987 to that in 1993?
Give a very brief answer. 0.39. What is the ratio of the Value added (current US$) in Services in 1987 to that in 1993?
Make the answer very short. 1.63. What is the ratio of the Value added (current US$) of Agriculture in 1987 to that in 1993?
Provide a short and direct response. 1.13. What is the ratio of the Value added (current US$) in Industry in 1987 to that in 1994?
Offer a terse response. 0.8. What is the ratio of the Value added (current US$) in Manufacturing in 1987 to that in 1994?
Offer a terse response. 0.57. What is the ratio of the Value added (current US$) of Services in 1987 to that in 1994?
Give a very brief answer. 1.69. What is the ratio of the Value added (current US$) in Agriculture in 1987 to that in 1994?
Provide a succinct answer. 0.78. What is the ratio of the Value added (current US$) in Industry in 1988 to that in 1989?
Your answer should be very brief. 1.12. What is the ratio of the Value added (current US$) in Manufacturing in 1988 to that in 1989?
Your answer should be very brief. 0.74. What is the ratio of the Value added (current US$) in Services in 1988 to that in 1989?
Your answer should be very brief. 0.9. What is the ratio of the Value added (current US$) in Agriculture in 1988 to that in 1989?
Offer a very short reply. 0.91. What is the ratio of the Value added (current US$) of Industry in 1988 to that in 1990?
Make the answer very short. 1.21. What is the ratio of the Value added (current US$) in Manufacturing in 1988 to that in 1990?
Make the answer very short. 1.22. What is the ratio of the Value added (current US$) in Services in 1988 to that in 1990?
Your response must be concise. 0.83. What is the ratio of the Value added (current US$) of Agriculture in 1988 to that in 1990?
Offer a terse response. 0.77. What is the ratio of the Value added (current US$) of Industry in 1988 to that in 1991?
Provide a succinct answer. 1.17. What is the ratio of the Value added (current US$) of Manufacturing in 1988 to that in 1991?
Your answer should be compact. 1.24. What is the ratio of the Value added (current US$) of Services in 1988 to that in 1991?
Your answer should be very brief. 0.87. What is the ratio of the Value added (current US$) in Agriculture in 1988 to that in 1991?
Provide a short and direct response. 0.78. What is the ratio of the Value added (current US$) in Industry in 1988 to that in 1992?
Offer a very short reply. 2.97. What is the ratio of the Value added (current US$) of Manufacturing in 1988 to that in 1992?
Ensure brevity in your answer.  1.56. What is the ratio of the Value added (current US$) in Services in 1988 to that in 1992?
Offer a terse response. 0.4. What is the ratio of the Value added (current US$) in Agriculture in 1988 to that in 1992?
Give a very brief answer. 2.31. What is the ratio of the Value added (current US$) of Industry in 1988 to that in 1993?
Provide a succinct answer. 0.61. What is the ratio of the Value added (current US$) in Manufacturing in 1988 to that in 1993?
Your response must be concise. 1.68. What is the ratio of the Value added (current US$) in Services in 1988 to that in 1993?
Ensure brevity in your answer.  2.09. What is the ratio of the Value added (current US$) in Agriculture in 1988 to that in 1993?
Provide a succinct answer. 1.39. What is the ratio of the Value added (current US$) in Industry in 1988 to that in 1994?
Your answer should be very brief. 1.01. What is the ratio of the Value added (current US$) of Manufacturing in 1988 to that in 1994?
Make the answer very short. 2.47. What is the ratio of the Value added (current US$) in Services in 1988 to that in 1994?
Keep it short and to the point. 2.16. What is the ratio of the Value added (current US$) of Agriculture in 1988 to that in 1994?
Keep it short and to the point. 0.96. What is the ratio of the Value added (current US$) of Industry in 1989 to that in 1990?
Your answer should be very brief. 1.08. What is the ratio of the Value added (current US$) of Manufacturing in 1989 to that in 1990?
Give a very brief answer. 1.65. What is the ratio of the Value added (current US$) of Services in 1989 to that in 1990?
Offer a very short reply. 0.92. What is the ratio of the Value added (current US$) in Agriculture in 1989 to that in 1990?
Keep it short and to the point. 0.85. What is the ratio of the Value added (current US$) in Industry in 1989 to that in 1991?
Provide a short and direct response. 1.04. What is the ratio of the Value added (current US$) in Manufacturing in 1989 to that in 1991?
Offer a very short reply. 1.67. What is the ratio of the Value added (current US$) of Services in 1989 to that in 1991?
Keep it short and to the point. 0.97. What is the ratio of the Value added (current US$) of Agriculture in 1989 to that in 1991?
Offer a terse response. 0.85. What is the ratio of the Value added (current US$) in Industry in 1989 to that in 1992?
Make the answer very short. 2.64. What is the ratio of the Value added (current US$) in Manufacturing in 1989 to that in 1992?
Ensure brevity in your answer.  2.1. What is the ratio of the Value added (current US$) in Services in 1989 to that in 1992?
Your answer should be very brief. 0.45. What is the ratio of the Value added (current US$) of Agriculture in 1989 to that in 1992?
Your answer should be very brief. 2.53. What is the ratio of the Value added (current US$) in Industry in 1989 to that in 1993?
Provide a succinct answer. 0.54. What is the ratio of the Value added (current US$) of Manufacturing in 1989 to that in 1993?
Your answer should be compact. 2.25. What is the ratio of the Value added (current US$) in Services in 1989 to that in 1993?
Ensure brevity in your answer.  2.31. What is the ratio of the Value added (current US$) in Agriculture in 1989 to that in 1993?
Provide a succinct answer. 1.52. What is the ratio of the Value added (current US$) in Industry in 1989 to that in 1994?
Make the answer very short. 0.9. What is the ratio of the Value added (current US$) of Manufacturing in 1989 to that in 1994?
Provide a short and direct response. 3.32. What is the ratio of the Value added (current US$) in Services in 1989 to that in 1994?
Give a very brief answer. 2.39. What is the ratio of the Value added (current US$) in Agriculture in 1989 to that in 1994?
Give a very brief answer. 1.05. What is the ratio of the Value added (current US$) of Industry in 1990 to that in 1991?
Your answer should be compact. 0.97. What is the ratio of the Value added (current US$) in Services in 1990 to that in 1991?
Keep it short and to the point. 1.05. What is the ratio of the Value added (current US$) in Agriculture in 1990 to that in 1991?
Offer a terse response. 1.01. What is the ratio of the Value added (current US$) in Industry in 1990 to that in 1992?
Offer a very short reply. 2.45. What is the ratio of the Value added (current US$) of Manufacturing in 1990 to that in 1992?
Your answer should be very brief. 1.28. What is the ratio of the Value added (current US$) of Services in 1990 to that in 1992?
Your answer should be compact. 0.49. What is the ratio of the Value added (current US$) in Agriculture in 1990 to that in 1992?
Provide a succinct answer. 2.99. What is the ratio of the Value added (current US$) in Industry in 1990 to that in 1993?
Your answer should be very brief. 0.5. What is the ratio of the Value added (current US$) in Manufacturing in 1990 to that in 1993?
Make the answer very short. 1.37. What is the ratio of the Value added (current US$) in Services in 1990 to that in 1993?
Offer a terse response. 2.51. What is the ratio of the Value added (current US$) of Agriculture in 1990 to that in 1993?
Offer a very short reply. 1.8. What is the ratio of the Value added (current US$) in Industry in 1990 to that in 1994?
Keep it short and to the point. 0.83. What is the ratio of the Value added (current US$) in Manufacturing in 1990 to that in 1994?
Give a very brief answer. 2.01. What is the ratio of the Value added (current US$) in Services in 1990 to that in 1994?
Offer a terse response. 2.59. What is the ratio of the Value added (current US$) in Agriculture in 1990 to that in 1994?
Provide a short and direct response. 1.24. What is the ratio of the Value added (current US$) in Industry in 1991 to that in 1992?
Your answer should be very brief. 2.54. What is the ratio of the Value added (current US$) of Manufacturing in 1991 to that in 1992?
Offer a terse response. 1.26. What is the ratio of the Value added (current US$) in Services in 1991 to that in 1992?
Your response must be concise. 0.46. What is the ratio of the Value added (current US$) of Agriculture in 1991 to that in 1992?
Ensure brevity in your answer.  2.97. What is the ratio of the Value added (current US$) in Industry in 1991 to that in 1993?
Ensure brevity in your answer.  0.52. What is the ratio of the Value added (current US$) in Manufacturing in 1991 to that in 1993?
Offer a terse response. 1.35. What is the ratio of the Value added (current US$) in Services in 1991 to that in 1993?
Your answer should be compact. 2.39. What is the ratio of the Value added (current US$) in Agriculture in 1991 to that in 1993?
Ensure brevity in your answer.  1.79. What is the ratio of the Value added (current US$) of Industry in 1991 to that in 1994?
Provide a succinct answer. 0.86. What is the ratio of the Value added (current US$) of Manufacturing in 1991 to that in 1994?
Your response must be concise. 1.99. What is the ratio of the Value added (current US$) of Services in 1991 to that in 1994?
Your response must be concise. 2.47. What is the ratio of the Value added (current US$) in Agriculture in 1991 to that in 1994?
Keep it short and to the point. 1.23. What is the ratio of the Value added (current US$) in Industry in 1992 to that in 1993?
Provide a succinct answer. 0.21. What is the ratio of the Value added (current US$) in Manufacturing in 1992 to that in 1993?
Your answer should be very brief. 1.07. What is the ratio of the Value added (current US$) in Services in 1992 to that in 1993?
Your answer should be compact. 5.17. What is the ratio of the Value added (current US$) in Agriculture in 1992 to that in 1993?
Make the answer very short. 0.6. What is the ratio of the Value added (current US$) of Industry in 1992 to that in 1994?
Provide a succinct answer. 0.34. What is the ratio of the Value added (current US$) in Manufacturing in 1992 to that in 1994?
Provide a short and direct response. 1.58. What is the ratio of the Value added (current US$) in Services in 1992 to that in 1994?
Offer a terse response. 5.34. What is the ratio of the Value added (current US$) of Agriculture in 1992 to that in 1994?
Your answer should be compact. 0.42. What is the ratio of the Value added (current US$) of Industry in 1993 to that in 1994?
Keep it short and to the point. 1.66. What is the ratio of the Value added (current US$) of Manufacturing in 1993 to that in 1994?
Provide a succinct answer. 1.47. What is the ratio of the Value added (current US$) of Services in 1993 to that in 1994?
Make the answer very short. 1.03. What is the ratio of the Value added (current US$) of Agriculture in 1993 to that in 1994?
Your response must be concise. 0.69. What is the difference between the highest and the second highest Value added (current US$) in Industry?
Offer a very short reply. 7.41e+08. What is the difference between the highest and the second highest Value added (current US$) in Manufacturing?
Keep it short and to the point. 2.43e+08. What is the difference between the highest and the second highest Value added (current US$) in Services?
Ensure brevity in your answer.  1.31e+09. What is the difference between the highest and the second highest Value added (current US$) in Agriculture?
Your response must be concise. 8.80e+06. What is the difference between the highest and the lowest Value added (current US$) of Industry?
Ensure brevity in your answer.  1.51e+09. What is the difference between the highest and the lowest Value added (current US$) of Manufacturing?
Offer a terse response. 7.84e+08. What is the difference between the highest and the lowest Value added (current US$) in Services?
Provide a short and direct response. 2.07e+09. What is the difference between the highest and the lowest Value added (current US$) in Agriculture?
Offer a terse response. 6.94e+08. 